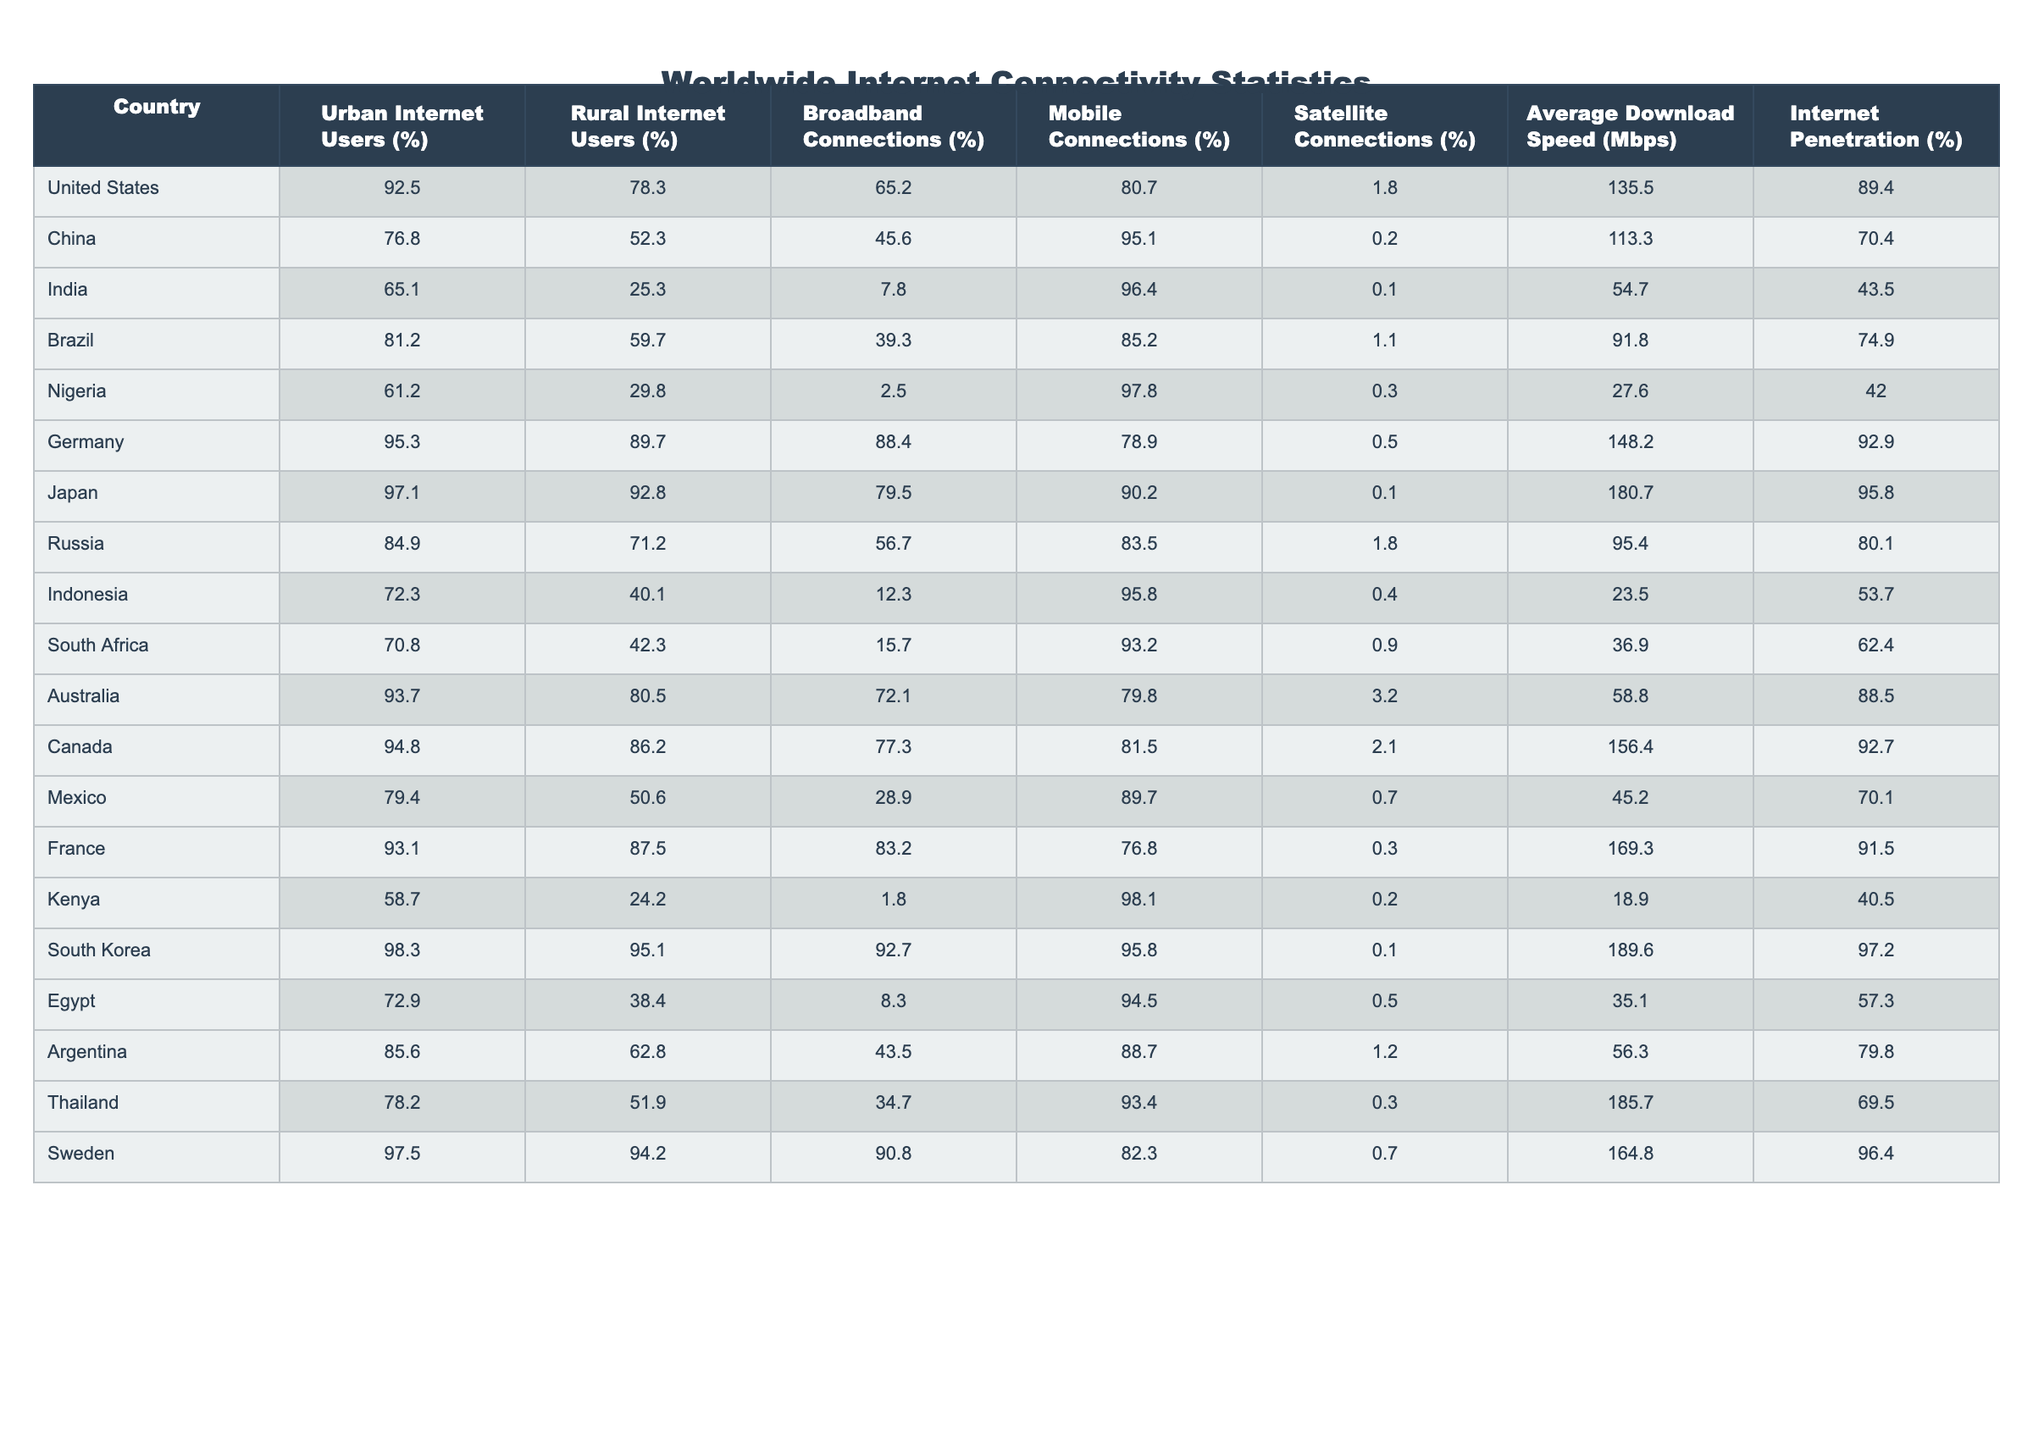What is the average internet penetration for the countries listed? To find the average internet penetration, sum the internet penetration percentages for all countries and divide by the number of countries. The sum is 89.4 + 70.4 + 43.5 + 74.9 + 42.0 + 92.9 + 95.8 + 80.1 + 53.7 + 62.4 + 88.5 + 92.7 + 70.1 + 40.5 + 97.2 + 57.3 + 79.8 + 69.5 + 96.4 = 1303.2, and there are 18 countries. Thus, the average is 1303.2 / 18 = approximately 72.5.
Answer: 72.5 Which country has the highest average download speed? From the table, United States has an average download speed of 135.5 Mbps, Germany has 148.2 Mbps, Japan has 180.7 Mbps, South Korea has 189.6 Mbps, and Sweden has 164.8 Mbps. South Korea has the highest average download speed of 189.6 Mbps.
Answer: South Korea Is the internet penetration in Nigeria higher than that in India? The internet penetration percentage for Nigeria is 42.0% while for India it is 43.5%. Since 42.0% is less than 43.5%, the statement is false.
Answer: No What is the difference in urban internet users percentage between China and the United States? The urban internet users percentage in the United States is 92.5% while in China it is 76.8%. The difference is 92.5% - 76.8% = 15.7%.
Answer: 15.7% Which connection type has the highest percentage in India? Looking at the connection types for India, the mobile connections percentage is 96.4%, broadband connections is only 7.8%, and satellite connections is 0.1%. Hence, mobile connections are the highest.
Answer: Mobile connections Is there a country where rural internet users percentage exceeds urban users percentage? In the table, Nigeria's rural internet users percentage is 29.8%, while urban is 61.2%. Since urban is higher, we analyze further. In other countries, such as India, rural is even lower (25.3%). Hence, there doesn't exist a country in this dataset where rural exceeds urban users percentage.
Answer: No What is the total percentage of broadband and satellite connections in Brazil? For Brazil, the broadband connections percentage is 39.3% and satellite connections is 1.1%. The total percentage is 39.3% + 1.1% = 40.4%.
Answer: 40.4% Which country has the lowest internet penetration and what is the value? Based on the table, Nigeria has the lowest internet penetration at 42.0%.
Answer: Nigeria, 42.0% What is the average rural internet users percentage among the top five countries with the highest average download speeds? The top five countries with the highest average download speeds are South Korea (95.1%), Japan (92.8%), Germany (89.7%), France (87.5%), and Sweden (94.2%). To calculate the average rural internet users percentage: (95.1% + 92.8% + 89.7% + 87.5% + 94.2%) / 5 = 91.86%.
Answer: 91.86% How does the broadband connections percentage in Canada compare to that in Germany? For Canada, the broadband connections are 77.3% and for Germany, it is 88.4%. Since 77.3% is lower than 88.4%, Canada has a lower broadband connection percentage compared to Germany.
Answer: Lower Which country has the closest percentage of urban and rural internet users? Checking the urban and rural users for each country, South Africa's urban percentage is 70.8% and rural is 42.3%. The difference (28.5%) is one of the smallest among the countries. Therefore, South Africa has the closest urban and rural internet users percentages.
Answer: South Africa 